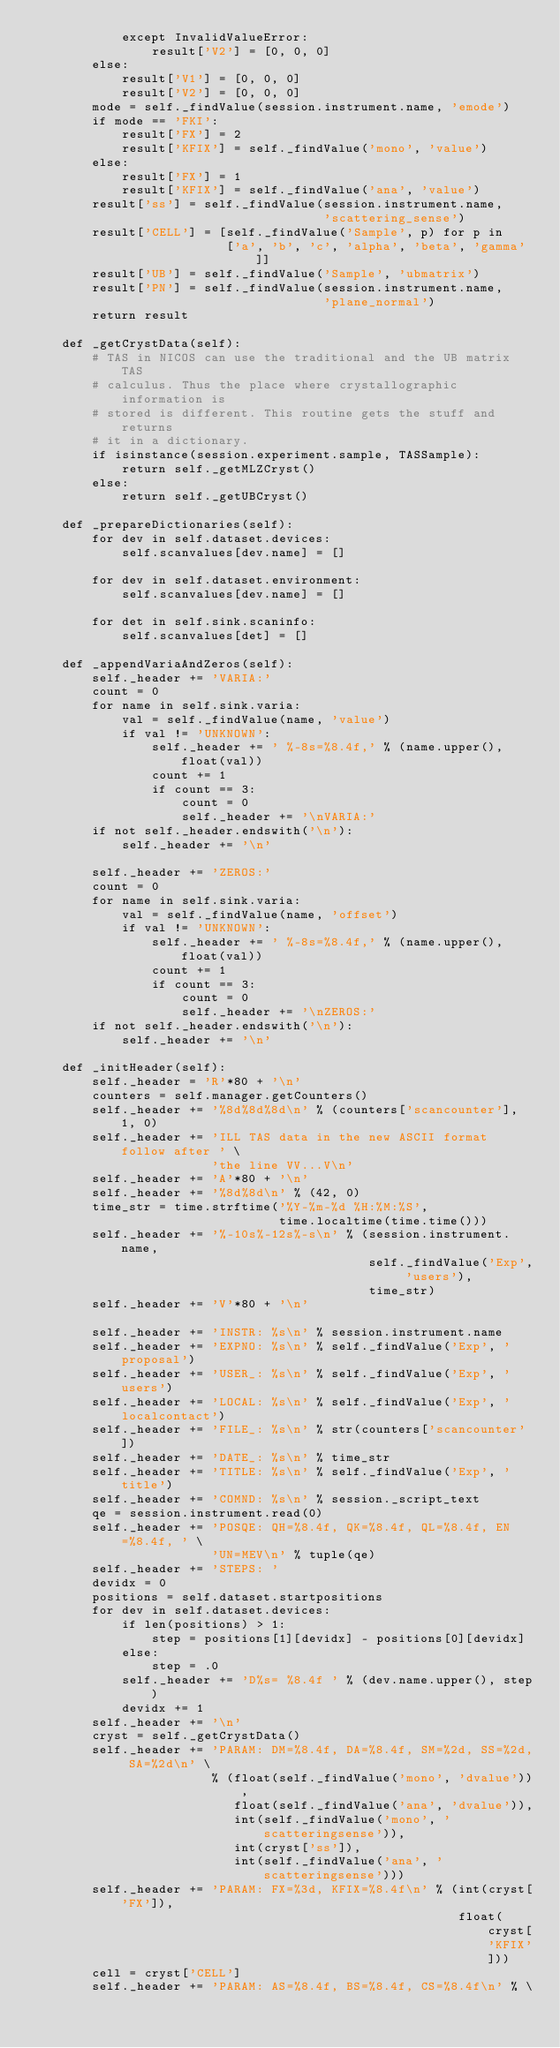<code> <loc_0><loc_0><loc_500><loc_500><_Python_>            except InvalidValueError:
                result['V2'] = [0, 0, 0]
        else:
            result['V1'] = [0, 0, 0]
            result['V2'] = [0, 0, 0]
        mode = self._findValue(session.instrument.name, 'emode')
        if mode == 'FKI':
            result['FX'] = 2
            result['KFIX'] = self._findValue('mono', 'value')
        else:
            result['FX'] = 1
            result['KFIX'] = self._findValue('ana', 'value')
        result['ss'] = self._findValue(session.instrument.name,
                                       'scattering_sense')
        result['CELL'] = [self._findValue('Sample', p) for p in
                          ['a', 'b', 'c', 'alpha', 'beta', 'gamma']]
        result['UB'] = self._findValue('Sample', 'ubmatrix')
        result['PN'] = self._findValue(session.instrument.name,
                                       'plane_normal')
        return result

    def _getCrystData(self):
        # TAS in NICOS can use the traditional and the UB matrix TAS
        # calculus. Thus the place where crystallographic information is
        # stored is different. This routine gets the stuff and returns
        # it in a dictionary.
        if isinstance(session.experiment.sample, TASSample):
            return self._getMLZCryst()
        else:
            return self._getUBCryst()

    def _prepareDictionaries(self):
        for dev in self.dataset.devices:
            self.scanvalues[dev.name] = []

        for dev in self.dataset.environment:
            self.scanvalues[dev.name] = []

        for det in self.sink.scaninfo:
            self.scanvalues[det] = []

    def _appendVariaAndZeros(self):
        self._header += 'VARIA:'
        count = 0
        for name in self.sink.varia:
            val = self._findValue(name, 'value')
            if val != 'UNKNOWN':
                self._header += ' %-8s=%8.4f,' % (name.upper(), float(val))
                count += 1
                if count == 3:
                    count = 0
                    self._header += '\nVARIA:'
        if not self._header.endswith('\n'):
            self._header += '\n'

        self._header += 'ZEROS:'
        count = 0
        for name in self.sink.varia:
            val = self._findValue(name, 'offset')
            if val != 'UNKNOWN':
                self._header += ' %-8s=%8.4f,' % (name.upper(), float(val))
                count += 1
                if count == 3:
                    count = 0
                    self._header += '\nZEROS:'
        if not self._header.endswith('\n'):
            self._header += '\n'

    def _initHeader(self):
        self._header = 'R'*80 + '\n'
        counters = self.manager.getCounters()
        self._header += '%8d%8d%8d\n' % (counters['scancounter'], 1, 0)
        self._header += 'ILL TAS data in the new ASCII format follow after ' \
                        'the line VV...V\n'
        self._header += 'A'*80 + '\n'
        self._header += '%8d%8d\n' % (42, 0)
        time_str = time.strftime('%Y-%m-%d %H:%M:%S',
                                 time.localtime(time.time()))
        self._header += '%-10s%-12s%-s\n' % (session.instrument.name,
                                             self._findValue('Exp', 'users'),
                                             time_str)
        self._header += 'V'*80 + '\n'

        self._header += 'INSTR: %s\n' % session.instrument.name
        self._header += 'EXPNO: %s\n' % self._findValue('Exp', 'proposal')
        self._header += 'USER_: %s\n' % self._findValue('Exp', 'users')
        self._header += 'LOCAL: %s\n' % self._findValue('Exp', 'localcontact')
        self._header += 'FILE_: %s\n' % str(counters['scancounter'])
        self._header += 'DATE_: %s\n' % time_str
        self._header += 'TITLE: %s\n' % self._findValue('Exp', 'title')
        self._header += 'COMND: %s\n' % session._script_text
        qe = session.instrument.read(0)
        self._header += 'POSQE: QH=%8.4f, QK=%8.4f, QL=%8.4f, EN=%8.4f, ' \
                        'UN=MEV\n' % tuple(qe)
        self._header += 'STEPS: '
        devidx = 0
        positions = self.dataset.startpositions
        for dev in self.dataset.devices:
            if len(positions) > 1:
                step = positions[1][devidx] - positions[0][devidx]
            else:
                step = .0
            self._header += 'D%s= %8.4f ' % (dev.name.upper(), step)
            devidx += 1
        self._header += '\n'
        cryst = self._getCrystData()
        self._header += 'PARAM: DM=%8.4f, DA=%8.4f, SM=%2d, SS=%2d, SA=%2d\n' \
                        % (float(self._findValue('mono', 'dvalue')),
                           float(self._findValue('ana', 'dvalue')),
                           int(self._findValue('mono', 'scatteringsense')),
                           int(cryst['ss']),
                           int(self._findValue('ana', 'scatteringsense')))
        self._header += 'PARAM: FX=%3d, KFIX=%8.4f\n' % (int(cryst['FX']),
                                                         float(cryst['KFIX']))
        cell = cryst['CELL']
        self._header += 'PARAM: AS=%8.4f, BS=%8.4f, CS=%8.4f\n' % \</code> 